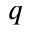<formula> <loc_0><loc_0><loc_500><loc_500>q</formula> 